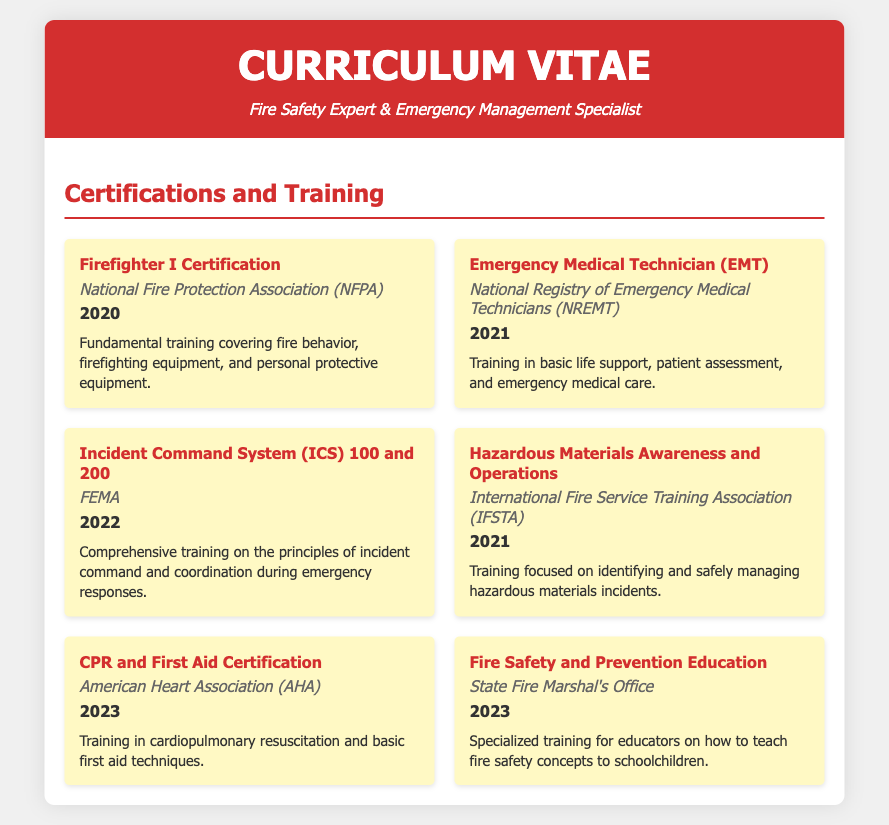What is the title of the document? The title is the heading at the top of the document, which states the professional role of the individual.
Answer: Curriculum Vitae Who issued the Firefighter I Certification? The issuing organization is mentioned alongside the certification in the document.
Answer: National Fire Protection Association (NFPA) In what year was the Emergency Medical Technician certification received? The year is specified below the certification name in the document.
Answer: 2021 What training is focused on hazardous materials? The certification name indicates the training related to hazardous materials.
Answer: Hazardous Materials Awareness and Operations Which certification was received most recently? The most recent certification will have the latest year mentioned in the document.
Answer: CPR and First Aid Certification How many certifications are listed in total? Counting all the certifications mentioned in the document will provide the total number.
Answer: Six What organization provided the training for fire safety education? This information is found below the relevant certification name in the document.
Answer: State Fire Marshal's Office What is the focus of the Incident Command System training? The description below the certification name specifies the focus of the training.
Answer: Principles of incident command and coordination Which certification focuses on teaching fire safety concepts? The certification name will indicate the specific training related to fire safety education.
Answer: Fire Safety and Prevention Education What is the purpose of CPR and First Aid Certification? The document's description outlines the skills learned in this certification.
Answer: Cardiopulmonary resuscitation and basic first aid techniques 